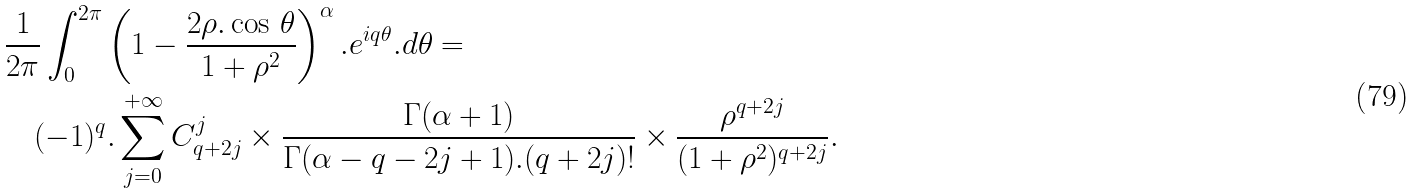Convert formula to latex. <formula><loc_0><loc_0><loc_500><loc_500>& \frac { 1 } { 2 \pi } \int _ { 0 } ^ { 2 \pi } \left ( 1 - \frac { 2 \rho . \cos \, \theta } { 1 + \rho ^ { 2 } } \right ) ^ { \alpha } . e ^ { i q \theta } . d \theta = \\ & \quad ( - 1 ) ^ { q } . \sum _ { j = 0 } ^ { + \infty } C _ { q + 2 j } ^ { j } \times \frac { \Gamma ( \alpha + 1 ) } { \Gamma ( \alpha - q - 2 j + 1 ) . ( q + 2 j ) ! } \times \frac { \rho ^ { q + 2 j } } { ( 1 + \rho ^ { 2 } ) ^ { q + 2 j } } .</formula> 